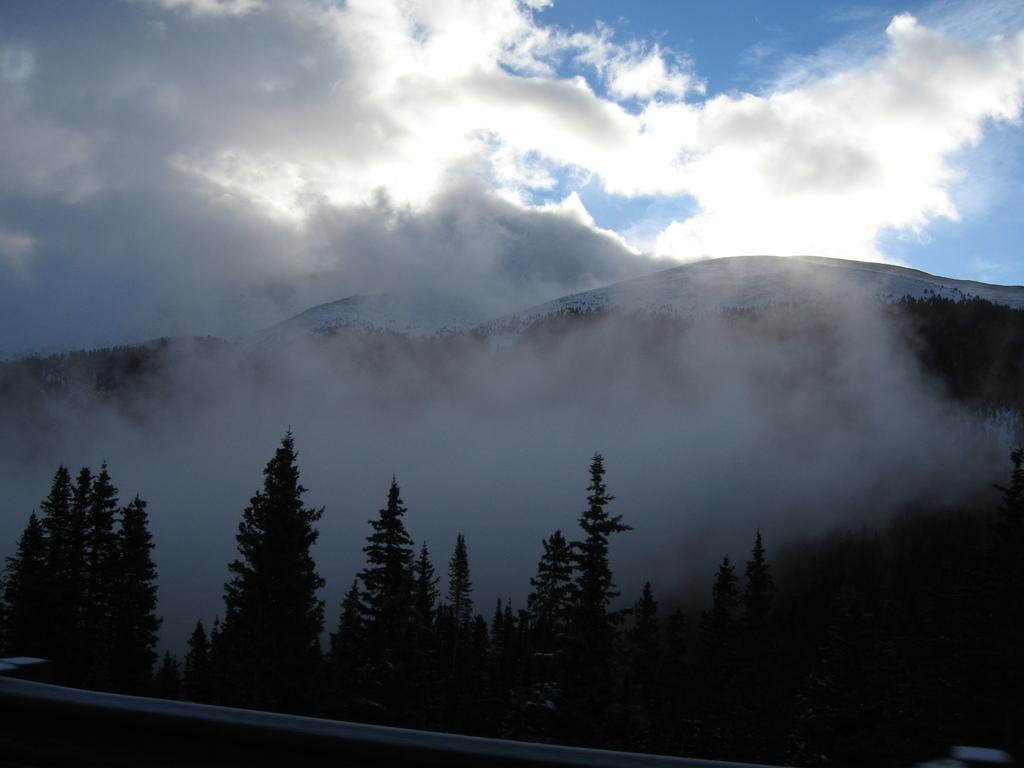What type of vegetation can be seen in the image? There are trees in the image. What natural phenomenon is present in the image? There is fog in the image. What geographical feature is visible in the image? There are mountains in the image. What is visible in the background of the image? The sky is visible in the background of the image. Can you hear the bell ringing in the image? There is no bell present in the image, so it cannot be heard. What type of bird can be seen flying in the image? There are no birds visible in the image; only trees, fog, mountains, and the sky are present. 